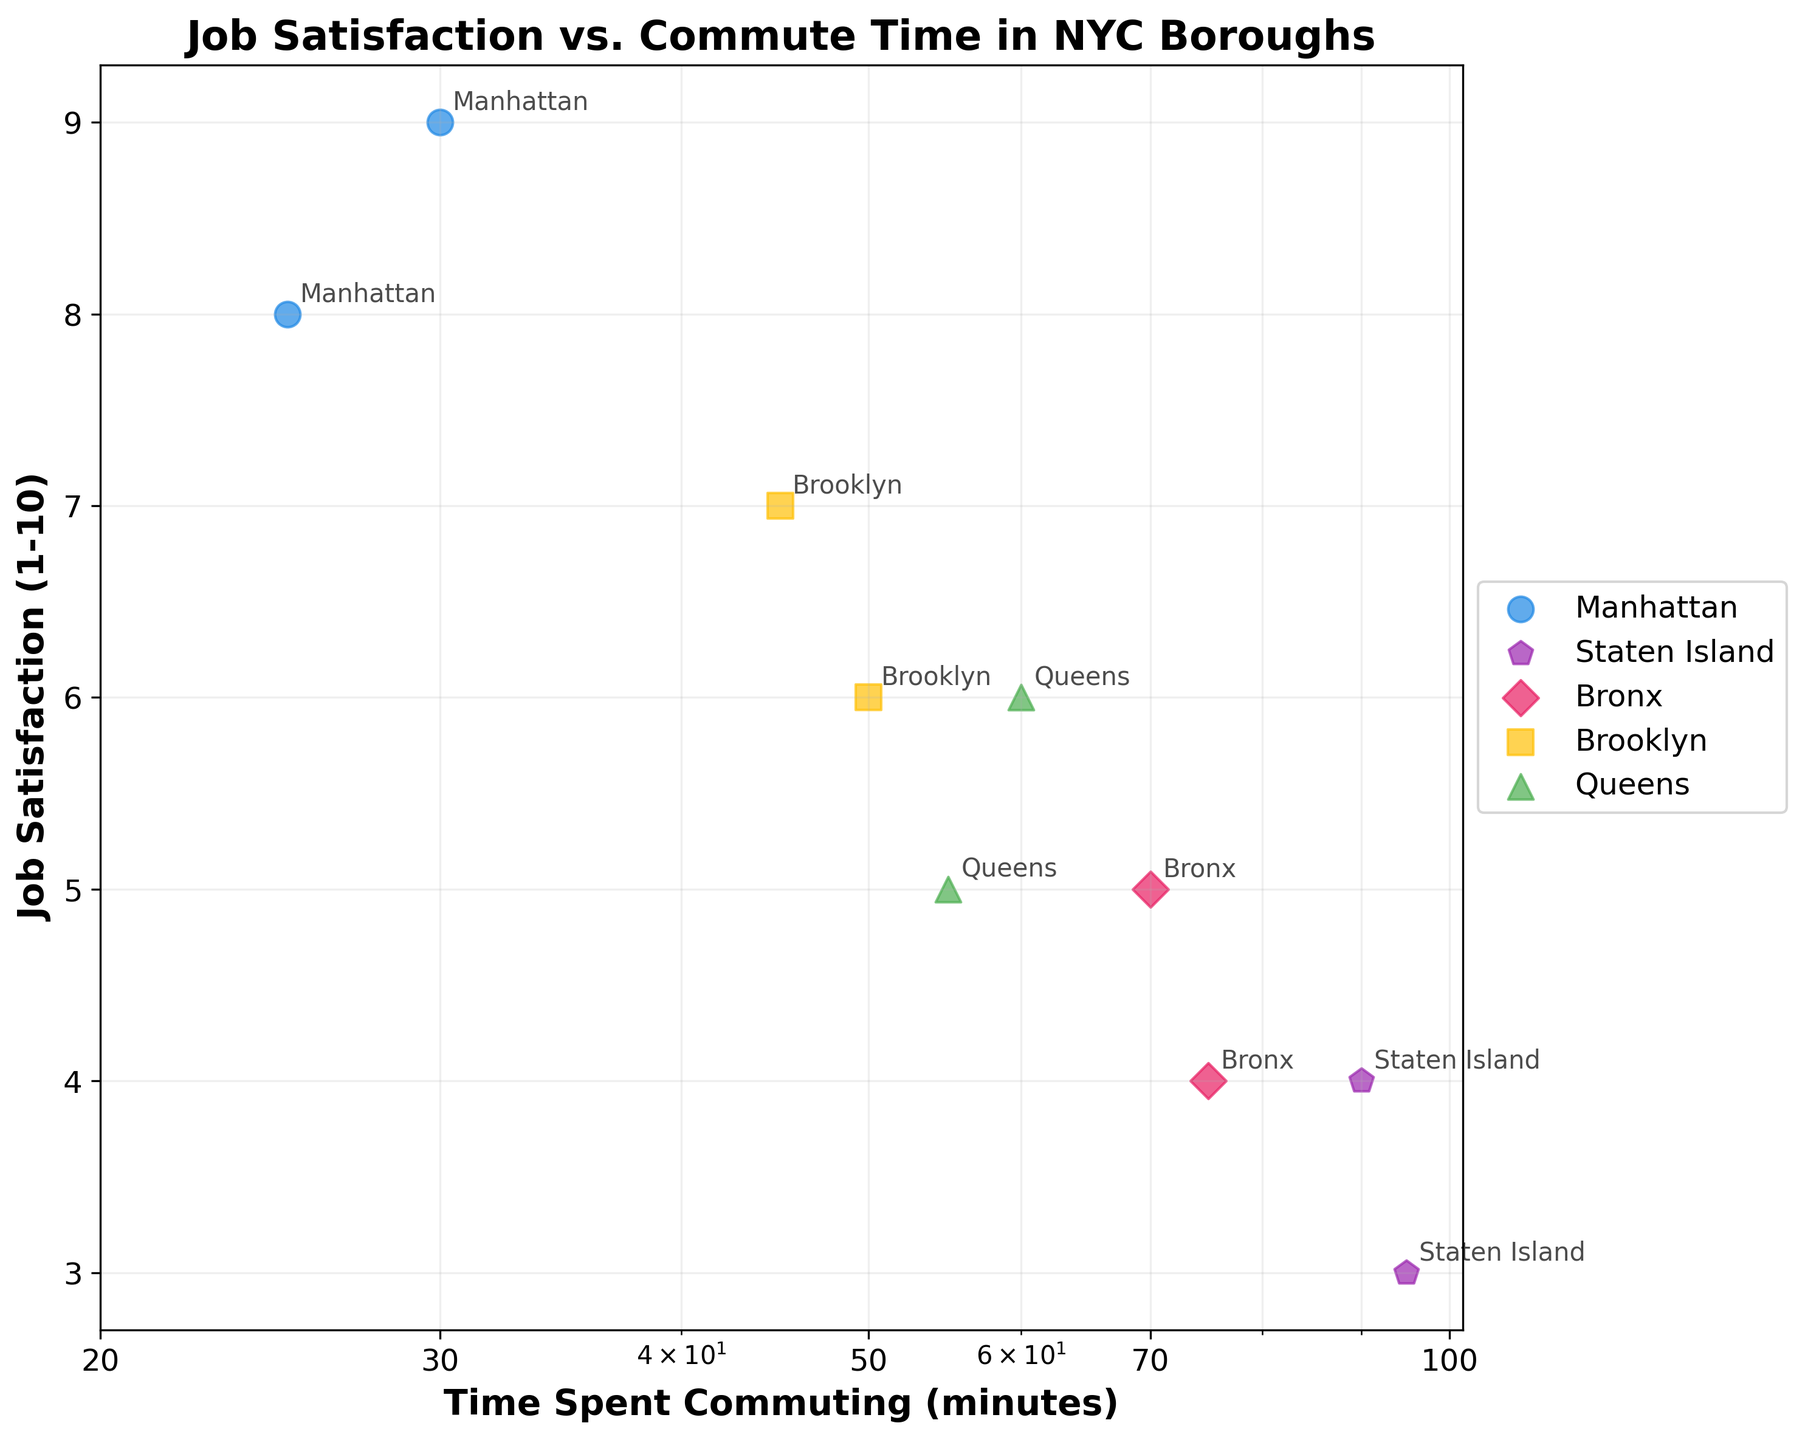What is the title of the plot? The title of the plot is displayed at the top of the figure.
Answer: Job Satisfaction vs. Commute Time in NYC Boroughs Which borough has the highest job satisfaction? The borough with the highest job satisfaction can be found as the data point with the highest y-value on the plot.
Answer: Manhattan What is the x-axis label? The x-axis label is displayed along the horizontal axis of the figure.
Answer: Time Spent Commuting (minutes) How many data points are there for Brooklyn? The number of data points for Brooklyn can be counted by locating the symbols corresponding to Brooklyn in the legend and counting those in the plot.
Answer: 2 What is the range of commute times displayed on the x-axis? The x-axis displays commute times in a log scale; by observing the tick marks, we can determine the range.
Answer: 20 to 100 minutes Which borough(s) have the lowest job satisfaction, and what is the corresponding commuting time? By identifying the data point(s) with the lowest y-value, we can find the borough(s) with the lowest job satisfaction and check their x-values for commuting time.
Answer: Staten Island, 90 and 95 minutes Is there a general trend between commute time and job satisfaction in the plot? By visually inspecting the scatter plot, we can observe if there is a general upward or downward trend between the axes.
Answer: As commuting time increases, job satisfaction generally decreases What is the difference in job satisfaction between the two data points for Manhattan? Identify the y-values for the two data points for Manhattan and calculate their difference.
Answer: 1 (9 - 8) Which borough has the widest range of job satisfaction values? Find the maximum and minimum job satisfaction values for each borough and compare the ranges.
Answer: Manhattan (range from 8 to 9) What is the average commuting time for the data points in Brooklyn? Identify the x-values for Brooklyn, sum them up, and divide by the number of data points.
Answer: (45 + 50) / 2 = 47.5 minutes 